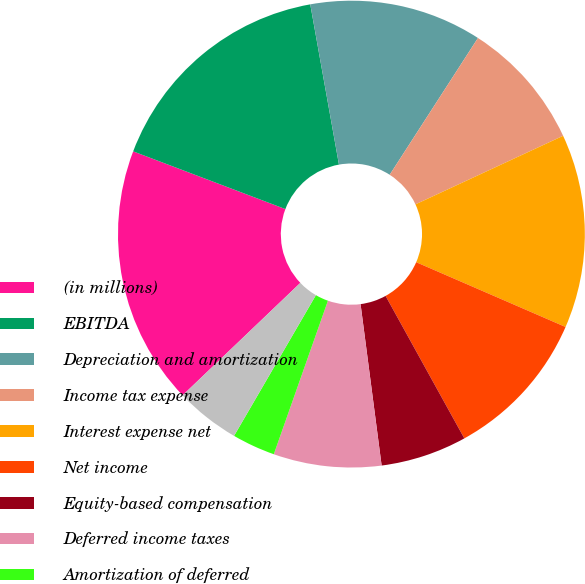Convert chart to OTSL. <chart><loc_0><loc_0><loc_500><loc_500><pie_chart><fcel>(in millions)<fcel>EBITDA<fcel>Depreciation and amortization<fcel>Income tax expense<fcel>Interest expense net<fcel>Net income<fcel>Equity-based compensation<fcel>Deferred income taxes<fcel>Amortization of deferred<fcel>Net loss on extinguishments of<nl><fcel>17.9%<fcel>16.41%<fcel>11.94%<fcel>8.96%<fcel>13.43%<fcel>10.45%<fcel>5.97%<fcel>7.46%<fcel>2.99%<fcel>4.48%<nl></chart> 